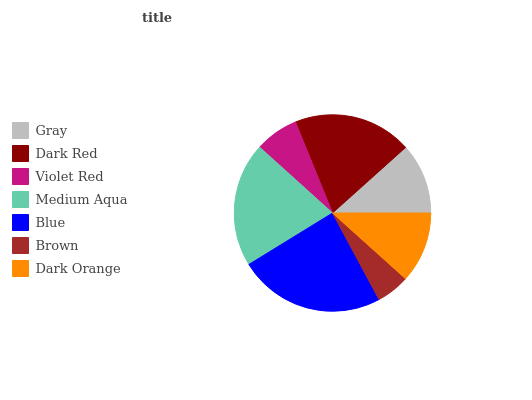Is Brown the minimum?
Answer yes or no. Yes. Is Blue the maximum?
Answer yes or no. Yes. Is Dark Red the minimum?
Answer yes or no. No. Is Dark Red the maximum?
Answer yes or no. No. Is Dark Red greater than Gray?
Answer yes or no. Yes. Is Gray less than Dark Red?
Answer yes or no. Yes. Is Gray greater than Dark Red?
Answer yes or no. No. Is Dark Red less than Gray?
Answer yes or no. No. Is Dark Orange the high median?
Answer yes or no. Yes. Is Dark Orange the low median?
Answer yes or no. Yes. Is Dark Red the high median?
Answer yes or no. No. Is Medium Aqua the low median?
Answer yes or no. No. 